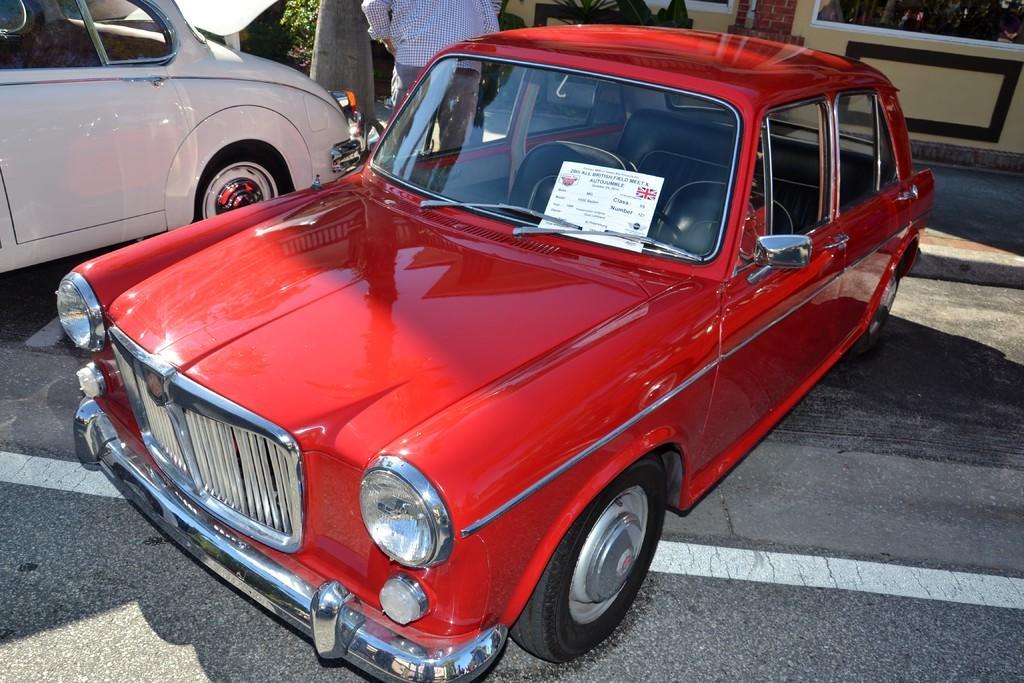Can you describe this image briefly? In this image, we can see a red car on the path. In the background, we can see a person, vehicle, plant, wall and walkway. 